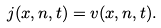<formula> <loc_0><loc_0><loc_500><loc_500>j ( x , n , t ) = v ( x , n , t ) .</formula> 